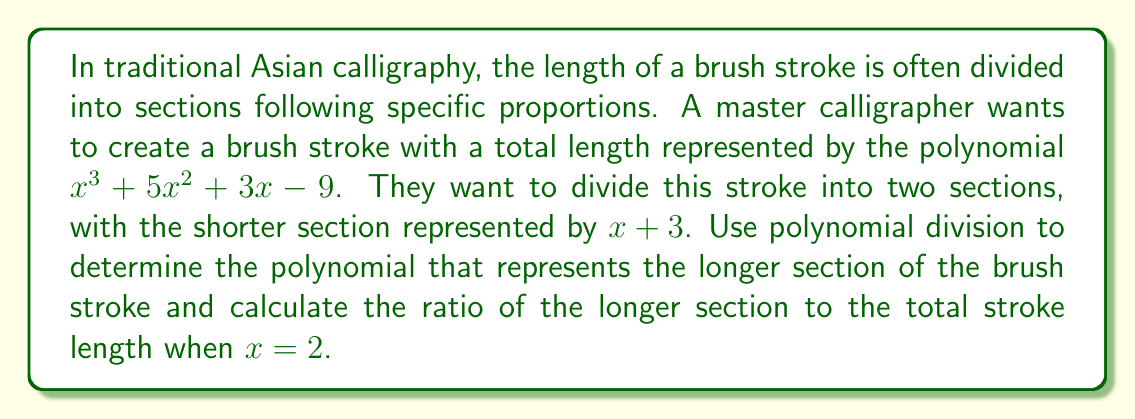Show me your answer to this math problem. Let's approach this step-by-step:

1) First, we need to perform polynomial division of $x^3 + 5x^2 + 3x - 9$ by $x + 3$:

   $$\begin{array}{r}
   x^2 + 2x - 6 \\
   x + 3 \enclose{longdiv}{x^3 + 5x^2 + 3x - 9} \\
   \underline{x^3 + 3x^2} \\
   2x^2 + 3x \\
   \underline{2x^2 + 6x} \\
   -3x - 9 \\
   \underline{-3x - 9} \\
   0
   \end{array}$$

2) The result of the division is $x^2 + 2x - 6$ with no remainder.

3) This means that the longer section of the brush stroke is represented by $x^2 + 2x - 6$.

4) To find the ratio of the longer section to the total stroke length when $x = 2$, we need to:
   a) Calculate the value of the longer section when $x = 2$
   b) Calculate the value of the total stroke when $x = 2$
   c) Divide these values

5) For the longer section $(x^2 + 2x - 6)$ when $x = 2$:
   $2^2 + 2(2) - 6 = 4 + 4 - 6 = 2$

6) For the total stroke $(x^3 + 5x^2 + 3x - 9)$ when $x = 2$:
   $2^3 + 5(2^2) + 3(2) - 9 = 8 + 20 + 6 - 9 = 25$

7) The ratio of the longer section to the total stroke is:
   $\frac{2}{25} = 0.08$
Answer: $0.08$ or $\frac{2}{25}$ 